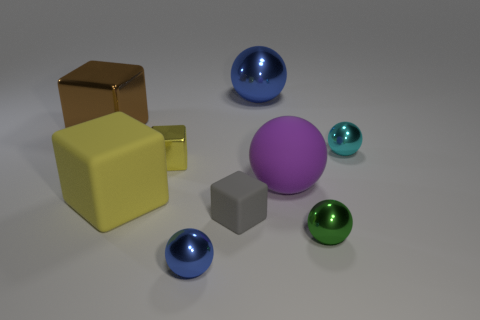What size is the other ball that is the same color as the big metallic sphere?
Provide a succinct answer. Small. Is the shape of the small yellow object the same as the gray rubber thing that is left of the green shiny object?
Provide a succinct answer. Yes. Are there any small gray things right of the small blue shiny sphere?
Your answer should be compact. Yes. There is another block that is the same color as the small metal block; what is its material?
Give a very brief answer. Rubber. What number of spheres are small cyan objects or large yellow matte objects?
Offer a very short reply. 1. Does the tiny cyan thing have the same shape as the yellow rubber thing?
Offer a very short reply. No. How big is the blue metallic sphere in front of the tiny green sphere?
Provide a succinct answer. Small. Are there any tiny shiny blocks of the same color as the big matte cube?
Provide a succinct answer. Yes. Does the blue metallic object that is right of the gray rubber cube have the same size as the big purple rubber sphere?
Provide a short and direct response. Yes. The tiny rubber object has what color?
Ensure brevity in your answer.  Gray. 